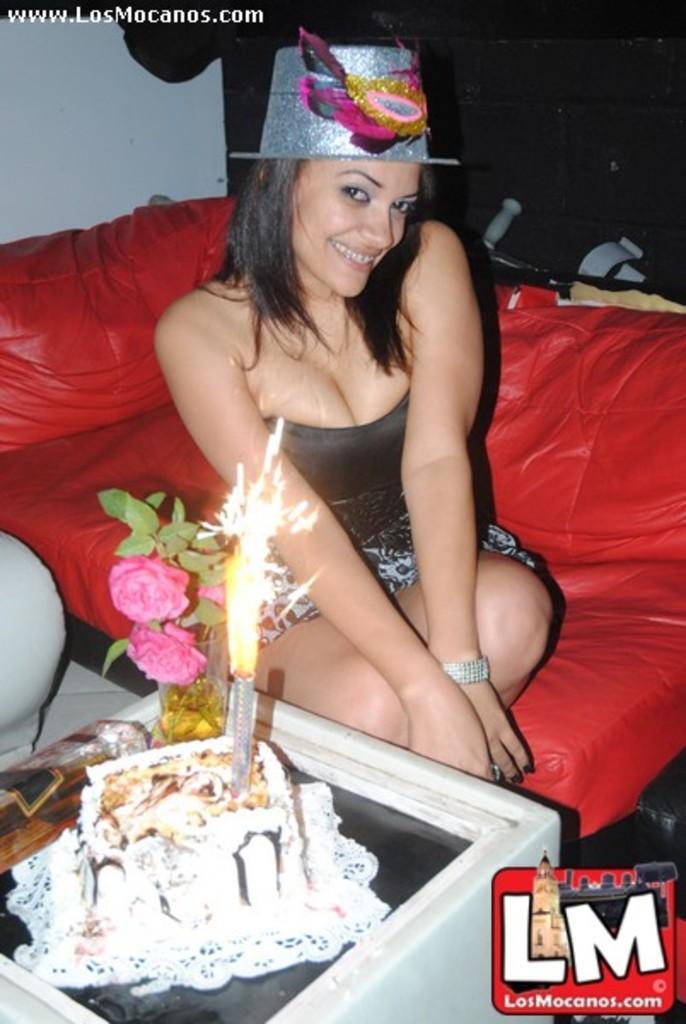Describe this image in one or two sentences. In this picture there is a girl in the center of the image on a sofa, she is wearing a hat and there is a cake and flowers in front of her. 